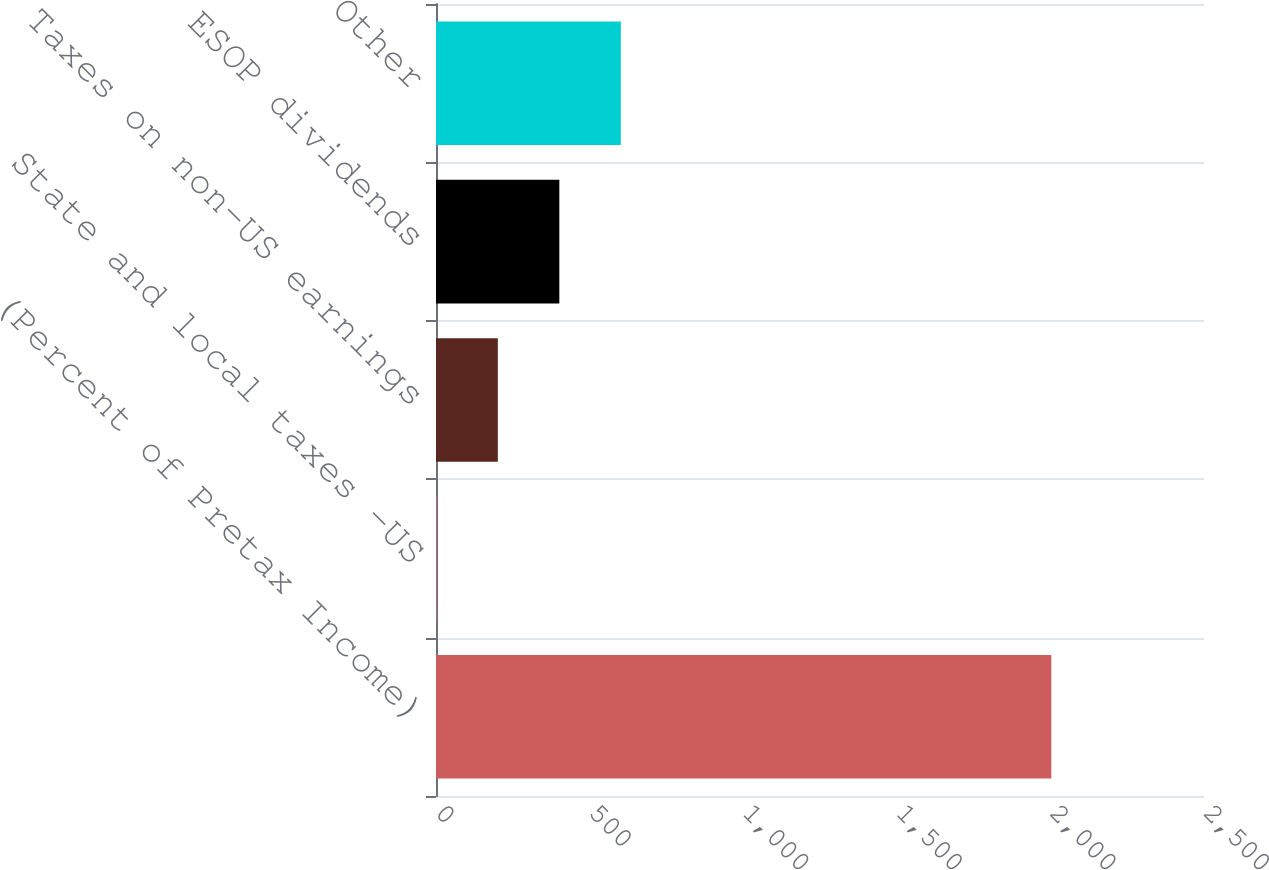Convert chart to OTSL. <chart><loc_0><loc_0><loc_500><loc_500><bar_chart><fcel>(Percent of Pretax Income)<fcel>State and local taxes -US<fcel>Taxes on non-US earnings<fcel>ESOP dividends<fcel>Other<nl><fcel>2003<fcel>1.1<fcel>201.29<fcel>401.48<fcel>601.67<nl></chart> 